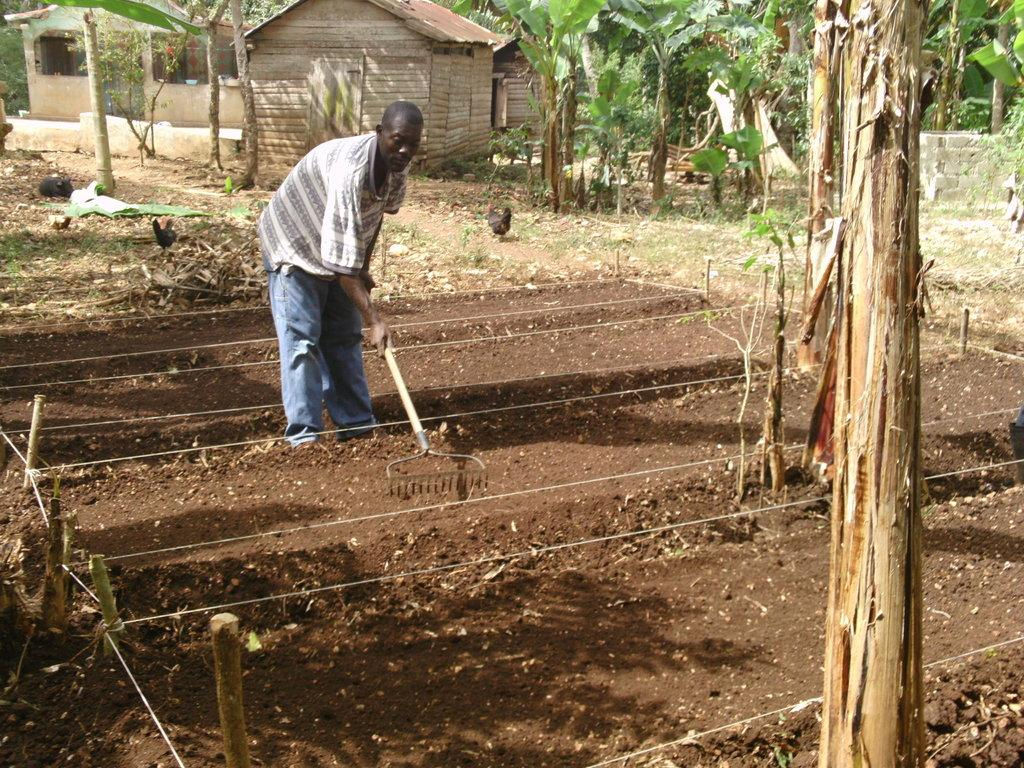What is present in the image? There is a person, soil, a rope, a wooden stick, grass, trees, a house, and a black hen in the image. What is the person wearing? The person is wearing clothes. What is the person holding in their hand? The person is holding an object in their hand. Can you describe the environment in the image? The image shows grass, trees, and a house, suggesting it is an outdoor setting. What other objects can be seen in the image? There is a rope and a wooden stick visible in the image. What type of sleet can be seen falling from the sky in the image? There is no sleet present in the image; it is a clear day with grass, trees, and a house visible. What is the chance of winning a prize in the image? There is no indication of a prize or a game in the image, so it is not possible to determine the chance of winning a prize. 